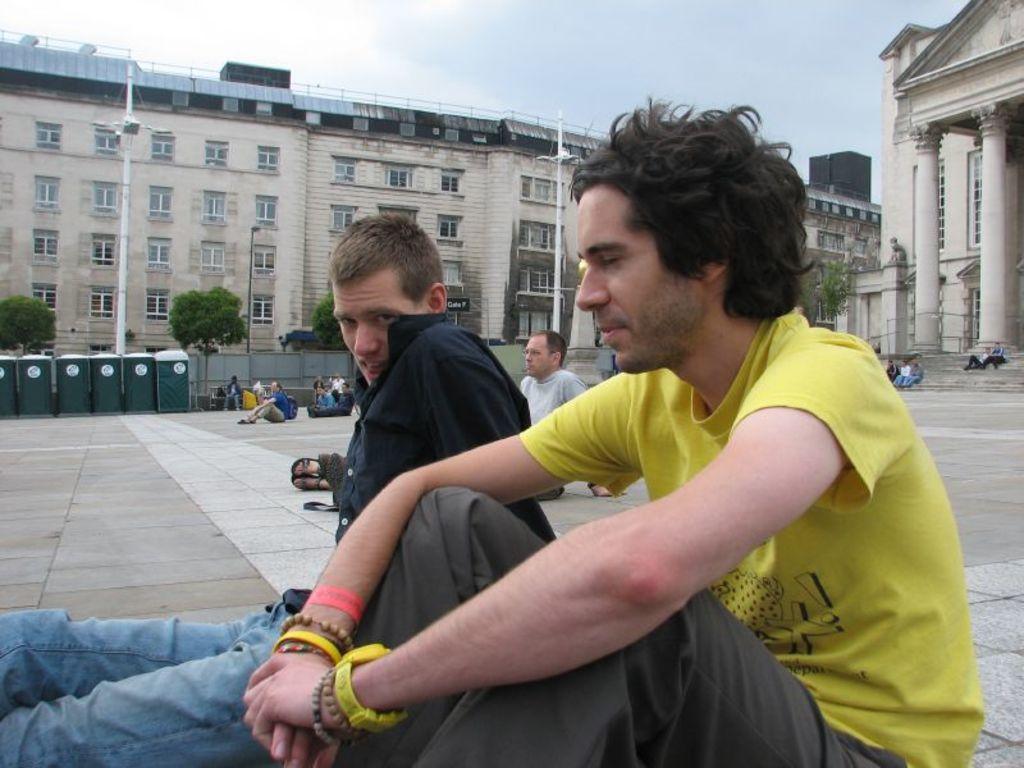How many people can be seen in the image? There are people in the image, but the exact number is not specified. What is visible beneath the people's feet in the image? The ground is visible in the image. What architectural features are present in the image? There are pillars, bins, buildings, and poles in the image. What type of vegetation is present in the image? There are trees in the image. What type of lighting is present in the image? There are lights in the image. What is visible in the background of the image? The sky is visible in the background of the image. How many fish can be seen swimming in the image? There are no fish present in the image. What color is the orange in the image? There is no orange present in the image. 